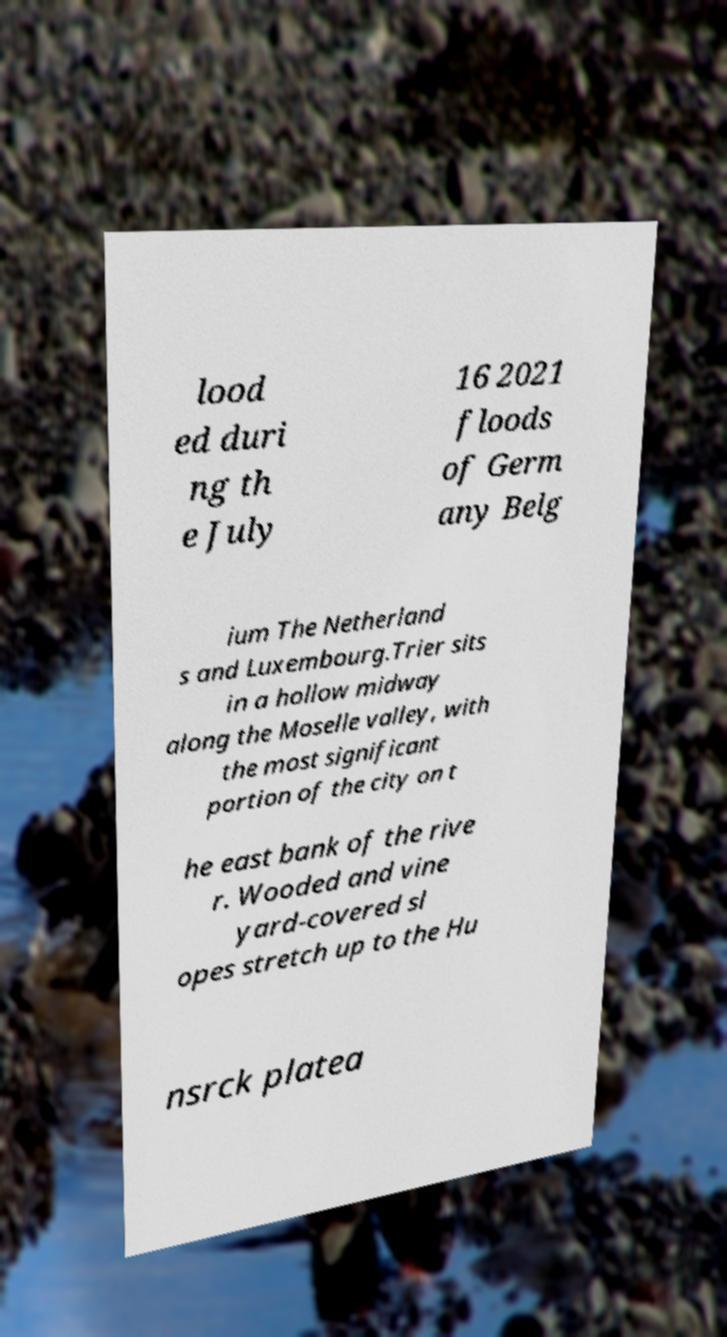Could you extract and type out the text from this image? lood ed duri ng th e July 16 2021 floods of Germ any Belg ium The Netherland s and Luxembourg.Trier sits in a hollow midway along the Moselle valley, with the most significant portion of the city on t he east bank of the rive r. Wooded and vine yard-covered sl opes stretch up to the Hu nsrck platea 